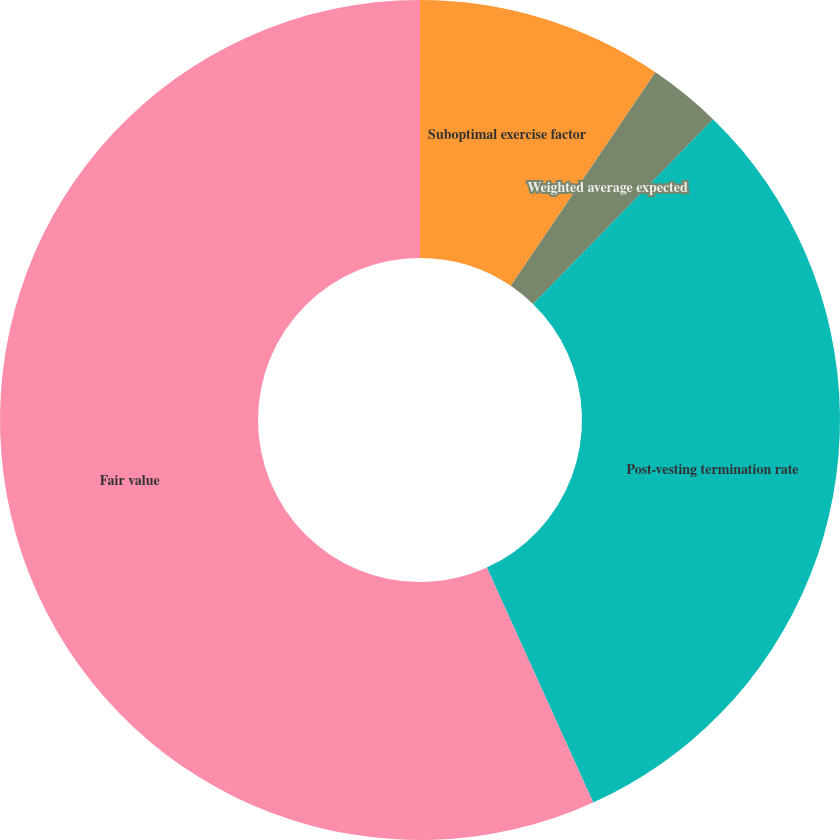Convert chart. <chart><loc_0><loc_0><loc_500><loc_500><pie_chart><fcel>Suboptimal exercise factor<fcel>Weighted average expected<fcel>Post-vesting termination rate<fcel>Fair value<nl><fcel>9.47%<fcel>2.82%<fcel>30.94%<fcel>56.76%<nl></chart> 